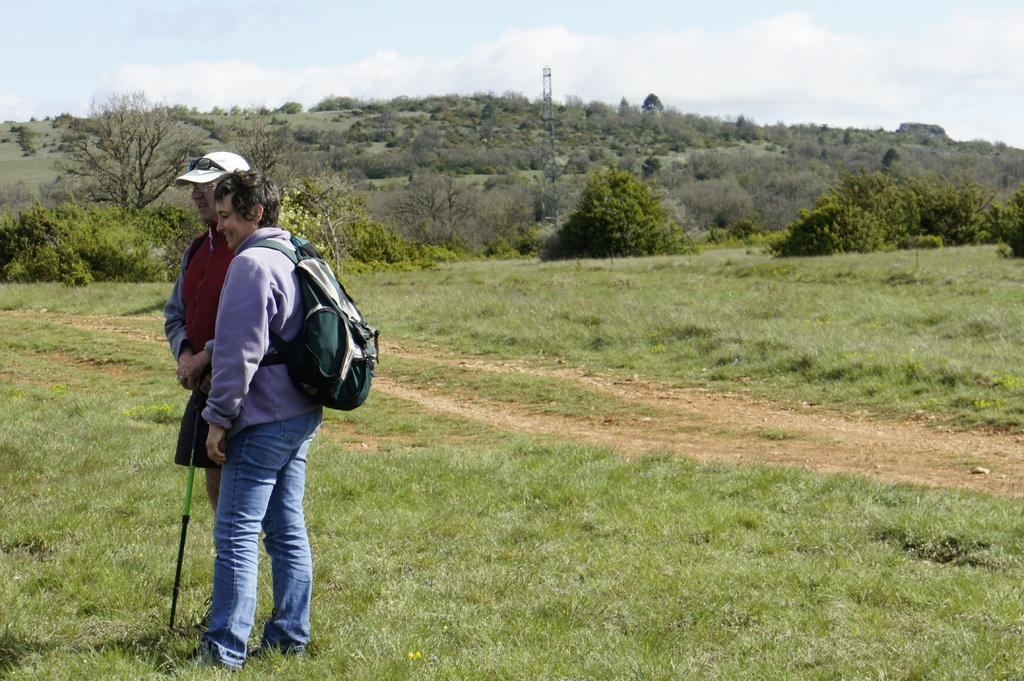How many people are in the image? There are two people in the image, a man and a woman. What is the man wearing on his head? The man is wearing a cap. What is the woman carrying in the image? The woman is carrying a bag. What can be seen in the background of the image? There are trees, grass, a tower, and the sky visible in the background of the image. What type of knife is the man using to cut the grass in the image? There is no knife present in the image, and the man is not cutting grass. 